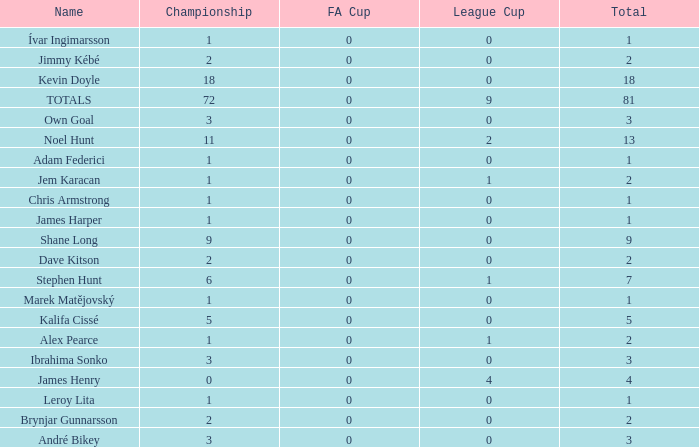What is the championship of Jem Karacan that has a total of 2 and a league cup more than 0? 1.0. 